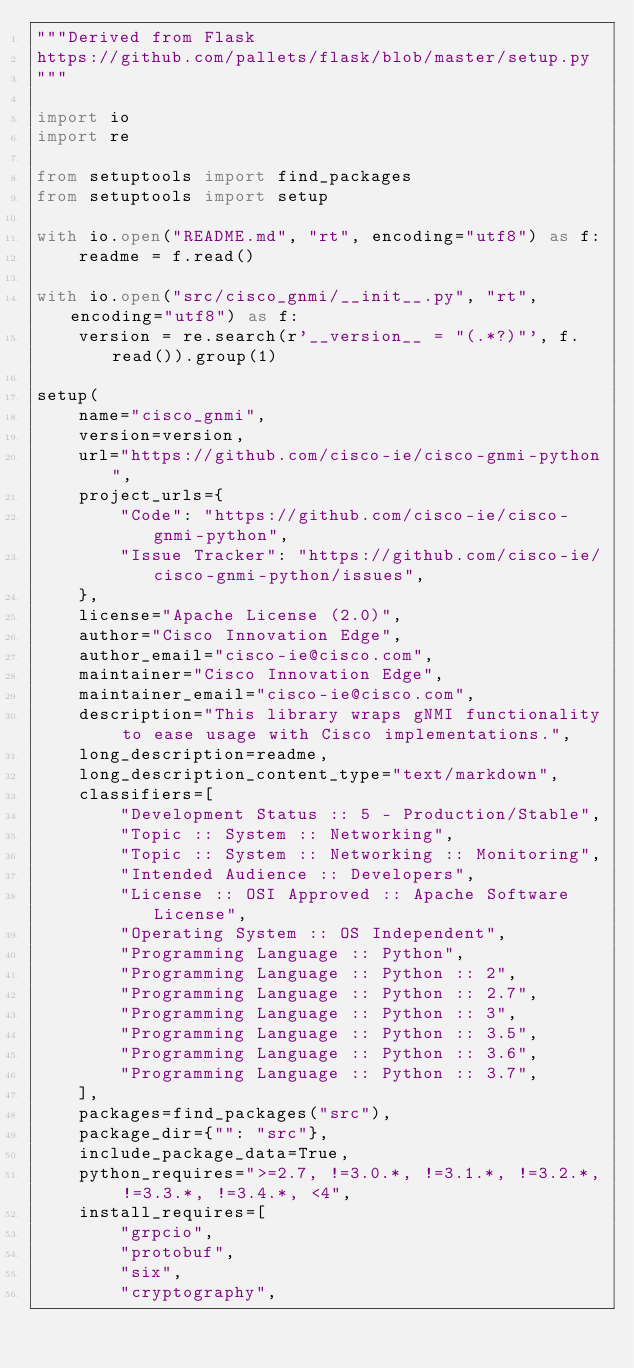<code> <loc_0><loc_0><loc_500><loc_500><_Python_>"""Derived from Flask
https://github.com/pallets/flask/blob/master/setup.py
"""

import io
import re

from setuptools import find_packages
from setuptools import setup

with io.open("README.md", "rt", encoding="utf8") as f:
    readme = f.read()

with io.open("src/cisco_gnmi/__init__.py", "rt", encoding="utf8") as f:
    version = re.search(r'__version__ = "(.*?)"', f.read()).group(1)

setup(
    name="cisco_gnmi",
    version=version,
    url="https://github.com/cisco-ie/cisco-gnmi-python",
    project_urls={
        "Code": "https://github.com/cisco-ie/cisco-gnmi-python",
        "Issue Tracker": "https://github.com/cisco-ie/cisco-gnmi-python/issues",
    },
    license="Apache License (2.0)",
    author="Cisco Innovation Edge",
    author_email="cisco-ie@cisco.com",
    maintainer="Cisco Innovation Edge",
    maintainer_email="cisco-ie@cisco.com",
    description="This library wraps gNMI functionality to ease usage with Cisco implementations.",
    long_description=readme,
    long_description_content_type="text/markdown",
    classifiers=[
        "Development Status :: 5 - Production/Stable",
        "Topic :: System :: Networking",
        "Topic :: System :: Networking :: Monitoring",
        "Intended Audience :: Developers",
        "License :: OSI Approved :: Apache Software License",
        "Operating System :: OS Independent",
        "Programming Language :: Python",
        "Programming Language :: Python :: 2",
        "Programming Language :: Python :: 2.7",
        "Programming Language :: Python :: 3",
        "Programming Language :: Python :: 3.5",
        "Programming Language :: Python :: 3.6",
        "Programming Language :: Python :: 3.7",
    ],
    packages=find_packages("src"),
    package_dir={"": "src"},
    include_package_data=True,
    python_requires=">=2.7, !=3.0.*, !=3.1.*, !=3.2.*, !=3.3.*, !=3.4.*, <4",
    install_requires=[
        "grpcio",
        "protobuf",
        "six",
        "cryptography",</code> 